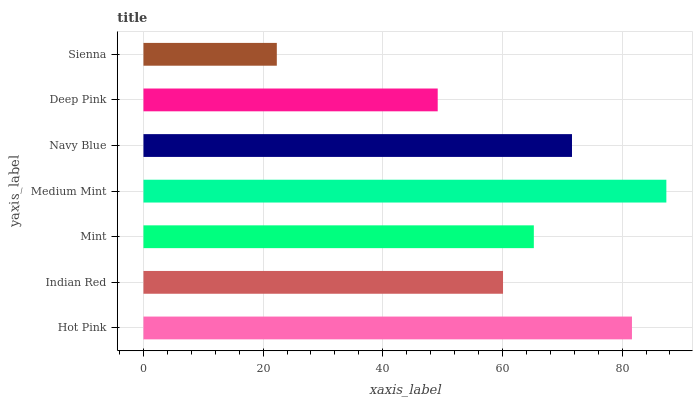Is Sienna the minimum?
Answer yes or no. Yes. Is Medium Mint the maximum?
Answer yes or no. Yes. Is Indian Red the minimum?
Answer yes or no. No. Is Indian Red the maximum?
Answer yes or no. No. Is Hot Pink greater than Indian Red?
Answer yes or no. Yes. Is Indian Red less than Hot Pink?
Answer yes or no. Yes. Is Indian Red greater than Hot Pink?
Answer yes or no. No. Is Hot Pink less than Indian Red?
Answer yes or no. No. Is Mint the high median?
Answer yes or no. Yes. Is Mint the low median?
Answer yes or no. Yes. Is Sienna the high median?
Answer yes or no. No. Is Medium Mint the low median?
Answer yes or no. No. 